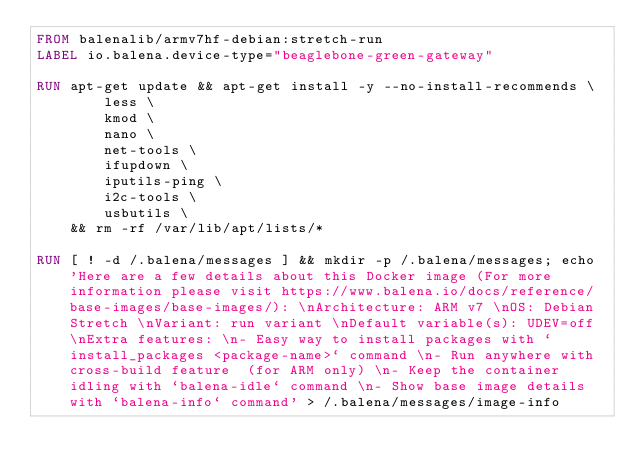Convert code to text. <code><loc_0><loc_0><loc_500><loc_500><_Dockerfile_>FROM balenalib/armv7hf-debian:stretch-run
LABEL io.balena.device-type="beaglebone-green-gateway"

RUN apt-get update && apt-get install -y --no-install-recommends \
		less \
		kmod \
		nano \
		net-tools \
		ifupdown \
		iputils-ping \
		i2c-tools \
		usbutils \
	&& rm -rf /var/lib/apt/lists/*

RUN [ ! -d /.balena/messages ] && mkdir -p /.balena/messages; echo 'Here are a few details about this Docker image (For more information please visit https://www.balena.io/docs/reference/base-images/base-images/): \nArchitecture: ARM v7 \nOS: Debian Stretch \nVariant: run variant \nDefault variable(s): UDEV=off \nExtra features: \n- Easy way to install packages with `install_packages <package-name>` command \n- Run anywhere with cross-build feature  (for ARM only) \n- Keep the container idling with `balena-idle` command \n- Show base image details with `balena-info` command' > /.balena/messages/image-info</code> 